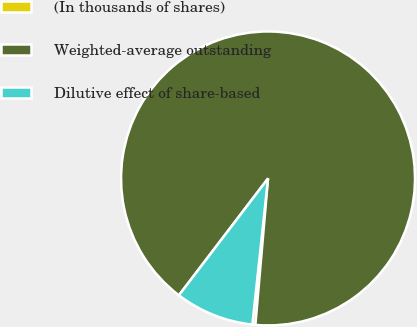<chart> <loc_0><loc_0><loc_500><loc_500><pie_chart><fcel>(In thousands of shares)<fcel>Weighted-average outstanding<fcel>Dilutive effect of share-based<nl><fcel>0.33%<fcel>90.99%<fcel>8.67%<nl></chart> 